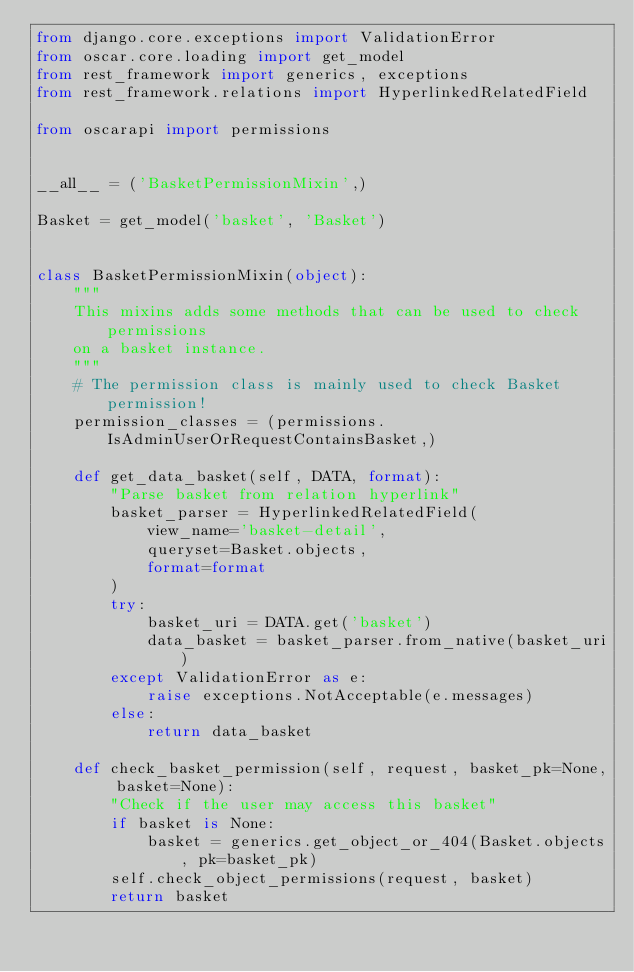Convert code to text. <code><loc_0><loc_0><loc_500><loc_500><_Python_>from django.core.exceptions import ValidationError
from oscar.core.loading import get_model
from rest_framework import generics, exceptions
from rest_framework.relations import HyperlinkedRelatedField

from oscarapi import permissions


__all__ = ('BasketPermissionMixin',)

Basket = get_model('basket', 'Basket')


class BasketPermissionMixin(object):
    """
    This mixins adds some methods that can be used to check permissions
    on a basket instance.
    """
    # The permission class is mainly used to check Basket permission!
    permission_classes = (permissions.IsAdminUserOrRequestContainsBasket,)

    def get_data_basket(self, DATA, format):
        "Parse basket from relation hyperlink"
        basket_parser = HyperlinkedRelatedField(
            view_name='basket-detail',
            queryset=Basket.objects,
            format=format
        )
        try:
            basket_uri = DATA.get('basket')
            data_basket = basket_parser.from_native(basket_uri)
        except ValidationError as e:
            raise exceptions.NotAcceptable(e.messages)
        else:
            return data_basket

    def check_basket_permission(self, request, basket_pk=None, basket=None):
        "Check if the user may access this basket"
        if basket is None:
            basket = generics.get_object_or_404(Basket.objects, pk=basket_pk)
        self.check_object_permissions(request, basket)
        return basket
</code> 